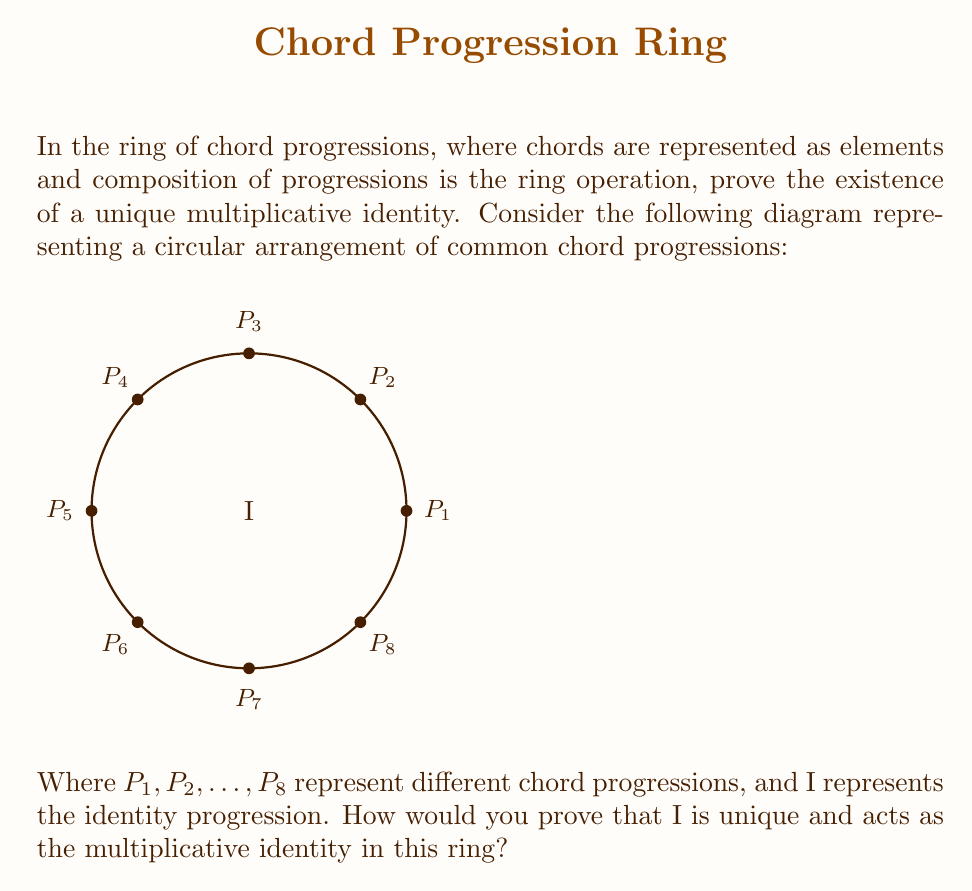Provide a solution to this math problem. To prove the existence of a unique multiplicative identity in the ring of chord progressions, we'll follow these steps:

1) First, let's define our ring $(R, +, \cdot)$ where $R$ is the set of all possible chord progressions, $+$ is the operation of concatenating progressions, and $\cdot$ is the operation of composing progressions.

2) The multiplicative identity, which we'll call $I$, must satisfy the following property for all progressions $P$ in $R$:

   $I \cdot P = P \cdot I = P$

3) In musical terms, $I$ would be a progression that, when composed with any other progression, leaves that progression unchanged. This is analogous to the concept of a "no-change" or "identity" progression.

4) To prove uniqueness, let's assume there are two identities $I_1$ and $I_2$. Then:

   $I_1 = I_1 \cdot I_2 = I_2$

   This shows that if two elements both satisfy the identity property, they must be equal.

5) To prove existence, we can consider the "empty" progression - a progression that doesn't change the harmonic context. This would act as our $I$.

6) For any progression $P$:
   $I \cdot P = P$ (composing with the empty progression doesn't change $P$)
   $P \cdot I = P$ (ending with the empty progression doesn't change $P$)

7) Therefore, $I$ satisfies the properties of a multiplicative identity.

In the context of our circular diagram, $I$ would be at the center, representing the fact that it composes neutrally with all other progressions around the circle.
Answer: The unique multiplicative identity in the ring of chord progressions is the empty progression $I$, which leaves any progression unchanged when composed with it. 